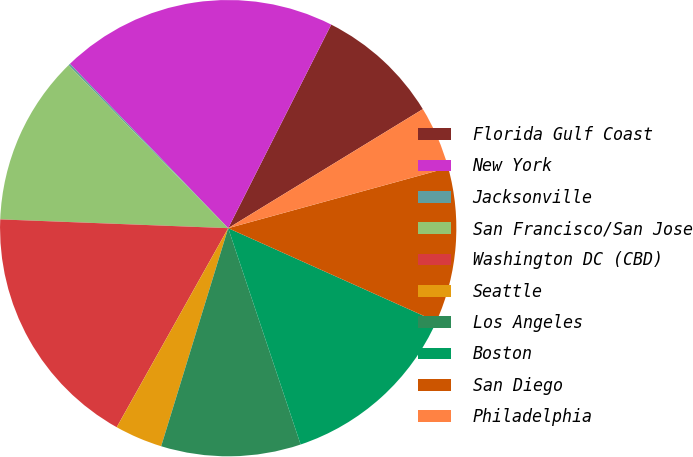Convert chart. <chart><loc_0><loc_0><loc_500><loc_500><pie_chart><fcel>Florida Gulf Coast<fcel>New York<fcel>Jacksonville<fcel>San Francisco/San Jose<fcel>Washington DC (CBD)<fcel>Seattle<fcel>Los Angeles<fcel>Boston<fcel>San Diego<fcel>Philadelphia<nl><fcel>8.81%<fcel>19.66%<fcel>0.13%<fcel>12.06%<fcel>17.49%<fcel>3.38%<fcel>9.89%<fcel>13.15%<fcel>10.98%<fcel>4.47%<nl></chart> 